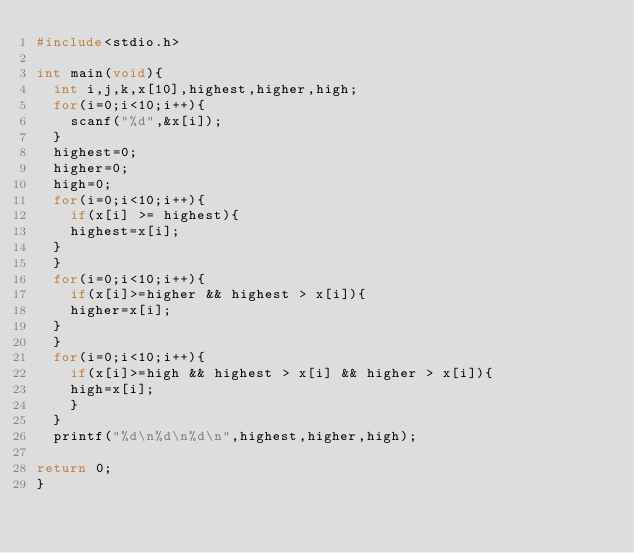Convert code to text. <code><loc_0><loc_0><loc_500><loc_500><_C_>#include<stdio.h>

int main(void){
	int i,j,k,x[10],highest,higher,high;
	for(i=0;i<10;i++){
		scanf("%d",&x[i]);
	}
	highest=0;
	higher=0;
	high=0;
	for(i=0;i<10;i++){
		if(x[i] >= highest){
		highest=x[i];
	}
	}
	for(i=0;i<10;i++){
		if(x[i]>=higher && highest > x[i]){
		higher=x[i];
	}
	}
	for(i=0;i<10;i++){
		if(x[i]>=high && highest > x[i] && higher > x[i]){
		high=x[i];
		}
	}
	printf("%d\n%d\n%d\n",highest,higher,high);
	
return 0;
}</code> 